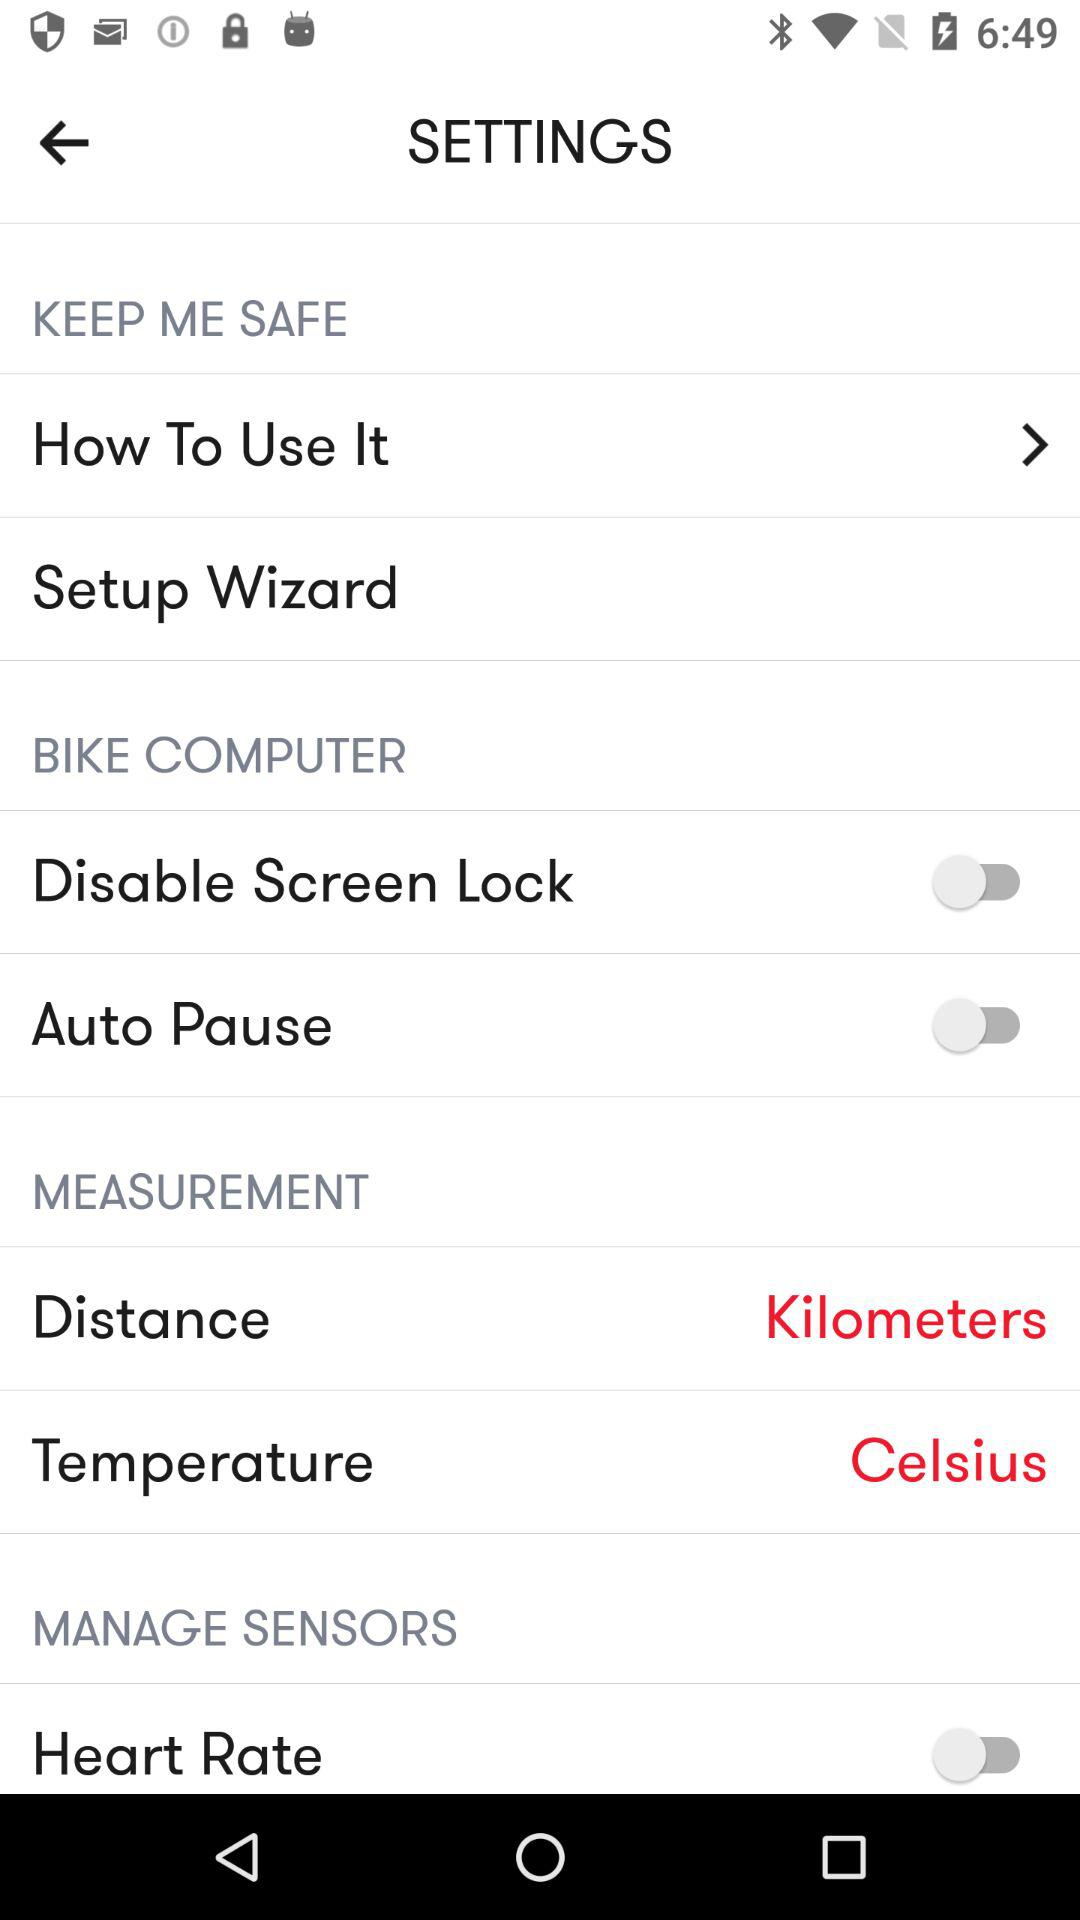What is the measurement unit for distance? The measurement unit for distance is kilometers. 